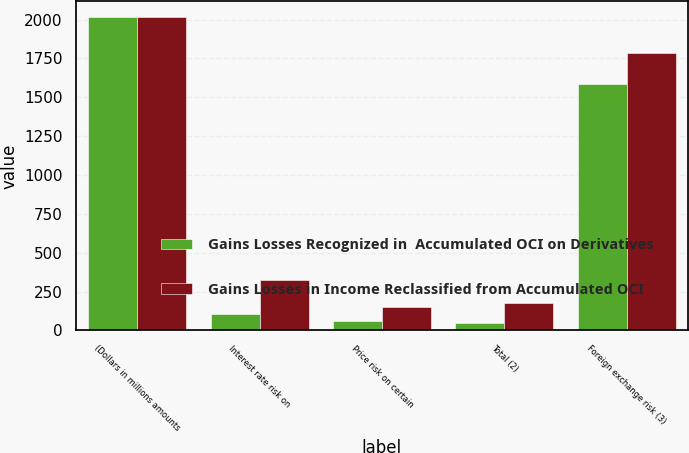<chart> <loc_0><loc_0><loc_500><loc_500><stacked_bar_chart><ecel><fcel>(Dollars in millions amounts<fcel>Interest rate risk on<fcel>Price risk on certain<fcel>Total (2)<fcel>Foreign exchange risk (3)<nl><fcel>Gains Losses Recognized in  Accumulated OCI on Derivatives<fcel>2017<fcel>109<fcel>59<fcel>50<fcel>1588<nl><fcel>Gains Losses in Income Reclassified from Accumulated OCI<fcel>2017<fcel>327<fcel>148<fcel>179<fcel>1782<nl></chart> 